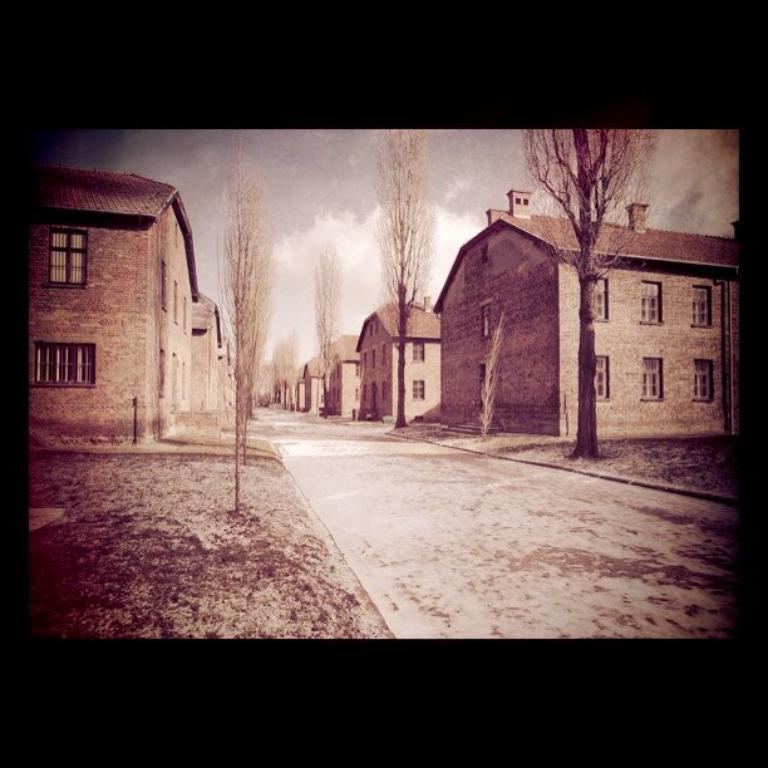In one or two sentences, can you explain what this image depicts? This picture seems to be an edited image with the black borders. In the foreground we can see the trees and the ground. In the center we can see the houses and we can see the windows of the houses. In the background there is a sky. 